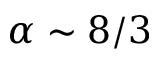<formula> <loc_0><loc_0><loc_500><loc_500>\alpha \sim 8 / 3</formula> 